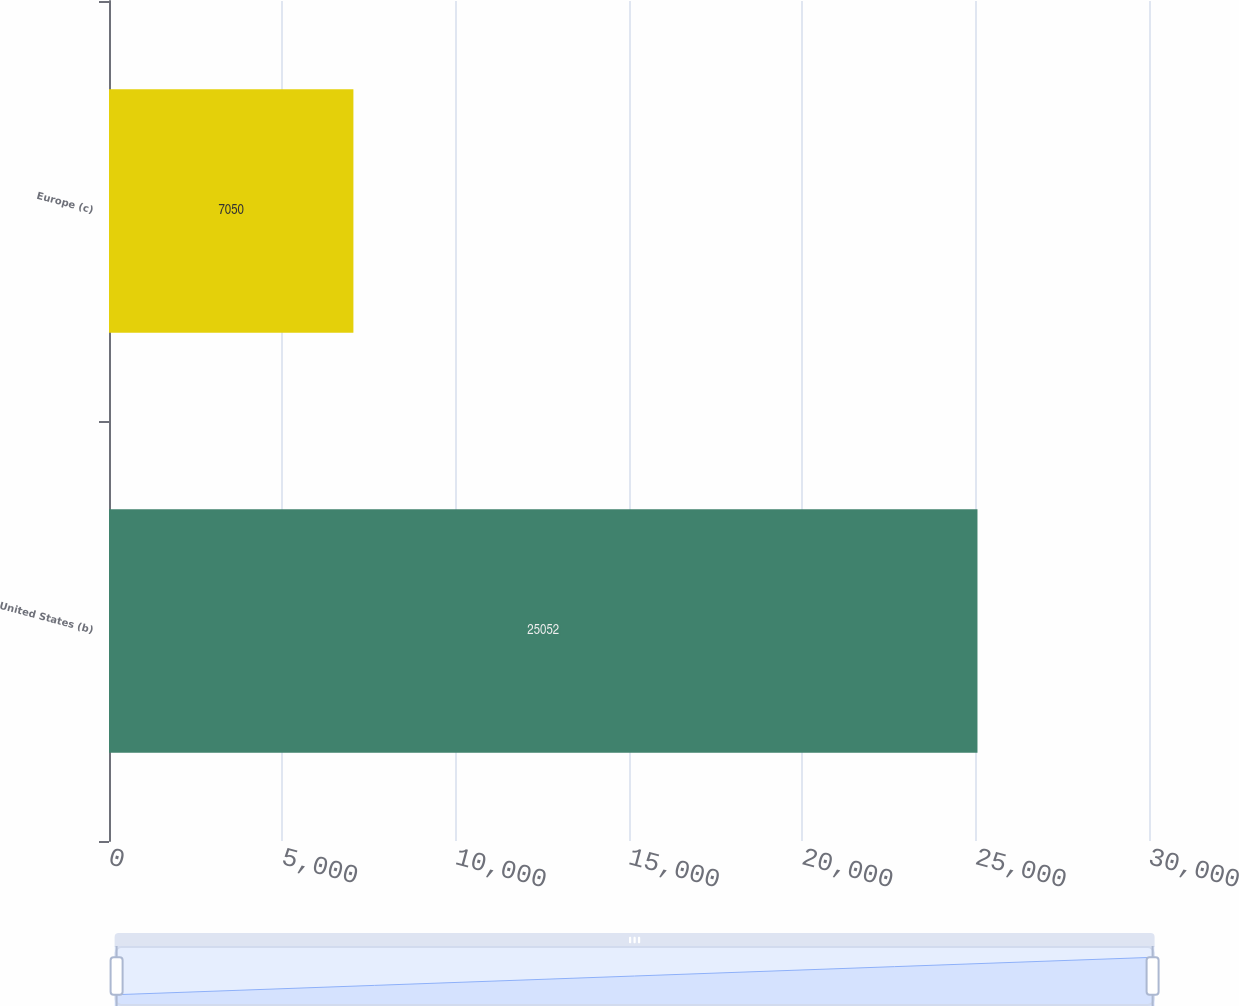Convert chart to OTSL. <chart><loc_0><loc_0><loc_500><loc_500><bar_chart><fcel>United States (b)<fcel>Europe (c)<nl><fcel>25052<fcel>7050<nl></chart> 